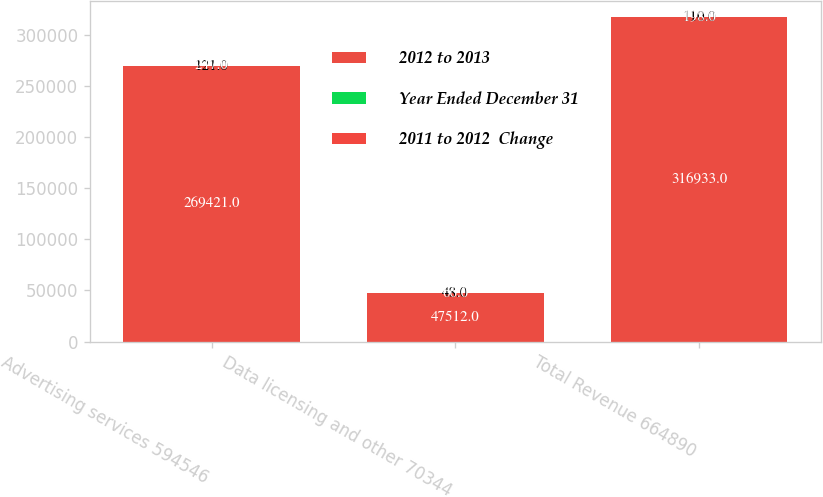Convert chart. <chart><loc_0><loc_0><loc_500><loc_500><stacked_bar_chart><ecel><fcel>Advertising services 594546<fcel>Data licensing and other 70344<fcel>Total Revenue 664890<nl><fcel>2012 to 2013<fcel>269421<fcel>47512<fcel>316933<nl><fcel>Year Ended December 31<fcel>121<fcel>48<fcel>110<nl><fcel>2011 to 2012  Change<fcel>247<fcel>66<fcel>198<nl></chart> 